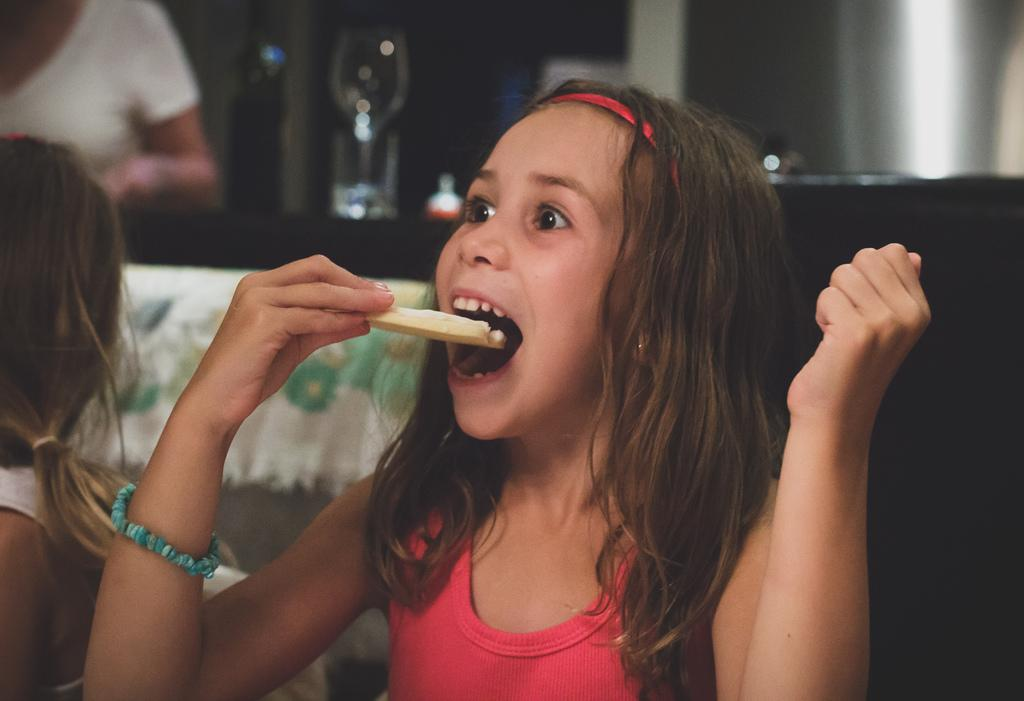What is the main subject of the image? The main subject of the image is a kid. What is the kid doing in the image? The kid has her mouth opened and is holding an edible in her hand. Is there anyone else in the image? Yes, there is another kid sitting beside her. What else can be seen in the image? There are other objects visible in the image. What is the rate of the plants growing in the image? There are no plants present in the image, so it is not possible to determine the rate of their growth. 